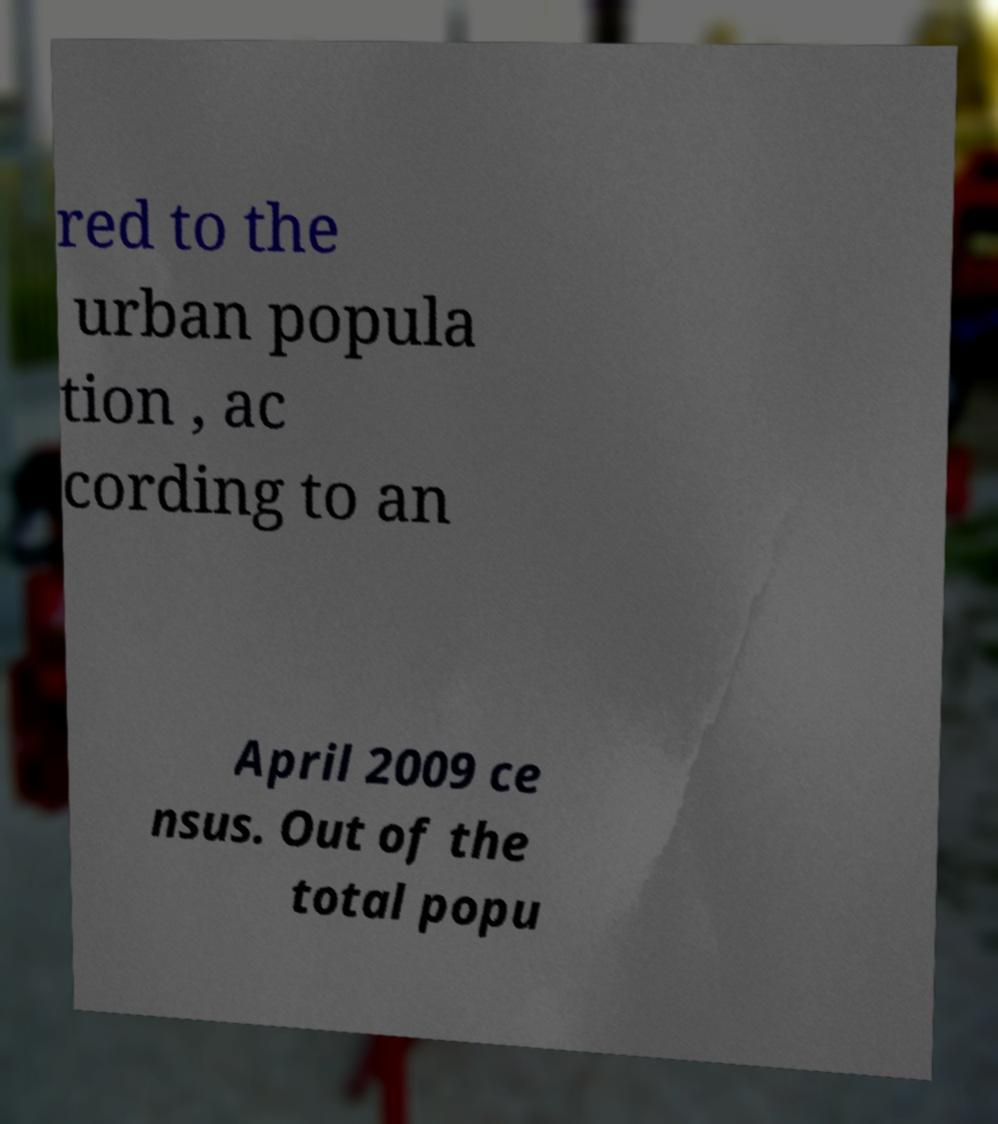Can you accurately transcribe the text from the provided image for me? red to the urban popula tion , ac cording to an April 2009 ce nsus. Out of the total popu 